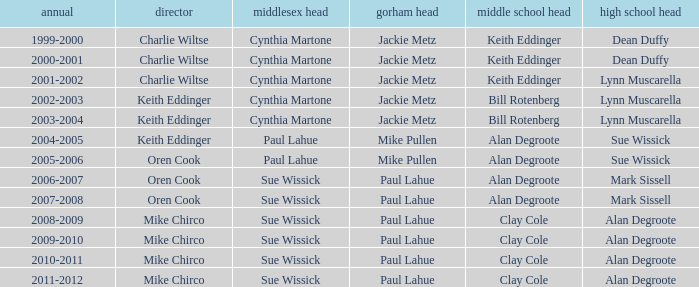Who was the gorham principal in 2010-2011? Paul Lahue. 